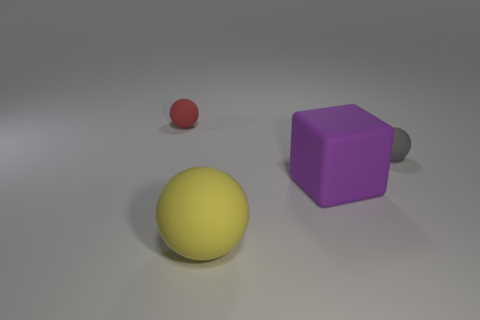Are there any other things that have the same shape as the gray object?
Give a very brief answer. Yes. What number of things are large yellow balls or red rubber spheres?
Your answer should be very brief. 2. There is a small gray matte thing; is it the same shape as the small matte object that is left of the large yellow matte sphere?
Make the answer very short. Yes. There is a thing to the right of the cube; what shape is it?
Your answer should be compact. Sphere. Is the gray rubber thing the same shape as the purple object?
Give a very brief answer. No. What is the size of the yellow rubber object that is the same shape as the gray rubber object?
Your response must be concise. Large. There is a matte sphere right of the purple cube; is its size the same as the yellow matte thing?
Your response must be concise. No. There is a sphere that is both behind the block and on the left side of the gray sphere; what is its size?
Your response must be concise. Small. Are there the same number of purple matte cubes in front of the tiny gray matte sphere and gray metallic objects?
Offer a terse response. No. What is the color of the matte block?
Offer a terse response. Purple. 